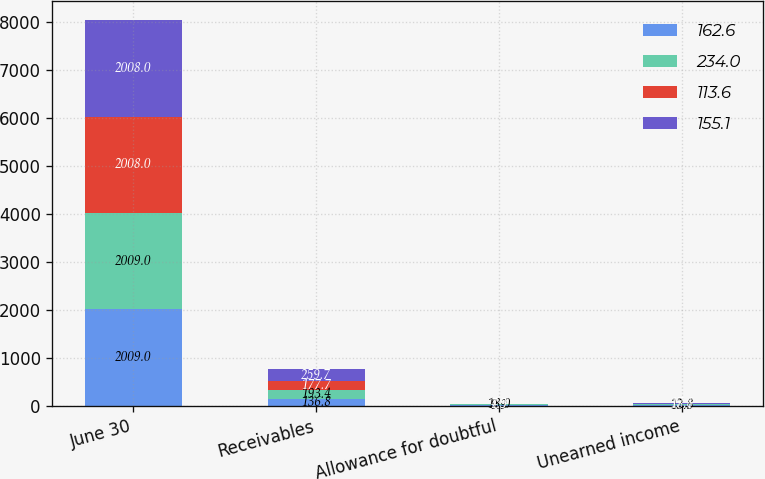Convert chart to OTSL. <chart><loc_0><loc_0><loc_500><loc_500><stacked_bar_chart><ecel><fcel>June 30<fcel>Receivables<fcel>Allowance for doubtful<fcel>Unearned income<nl><fcel>162.6<fcel>2009<fcel>136.8<fcel>9.9<fcel>13.3<nl><fcel>234<fcel>2009<fcel>193.4<fcel>18<fcel>12.8<nl><fcel>113.6<fcel>2008<fcel>177.7<fcel>4.5<fcel>18.1<nl><fcel>155.1<fcel>2008<fcel>259.7<fcel>7.9<fcel>17.8<nl></chart> 